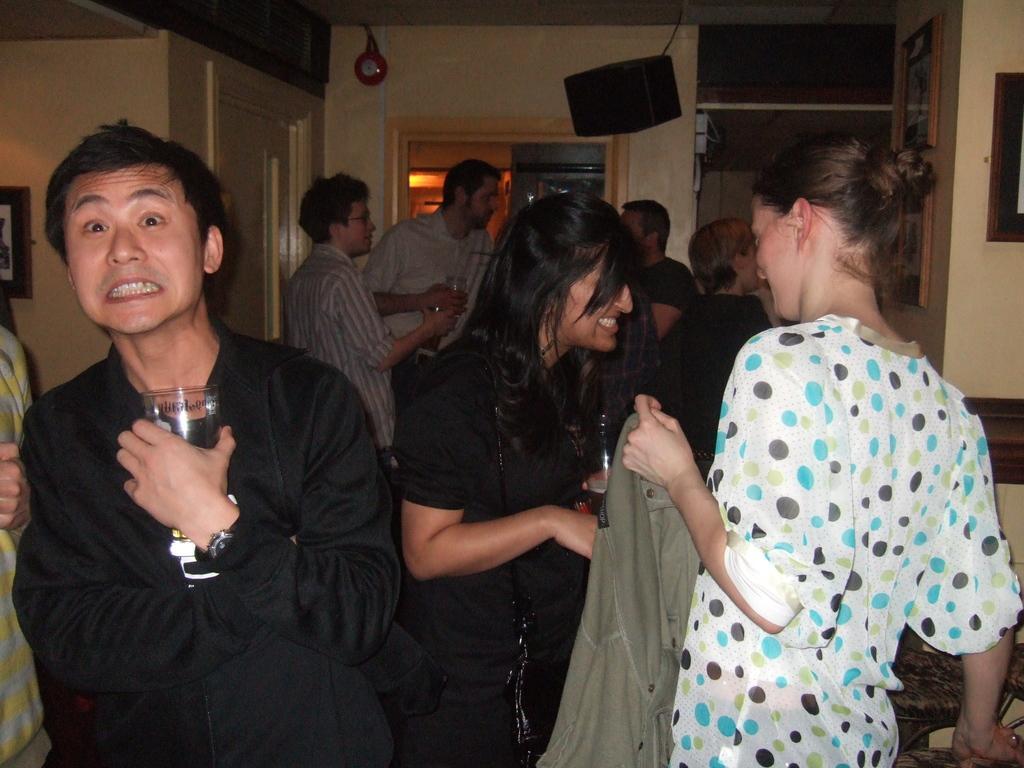Please provide a concise description of this image. In this image we can see few people standing in a room, few of them are holding glasses and a person is holding a cloth, there are few photo frames, a wall clock and a speaker on the wall, there is a door on the left side and on the right side of the image there are chairs beside the person. 